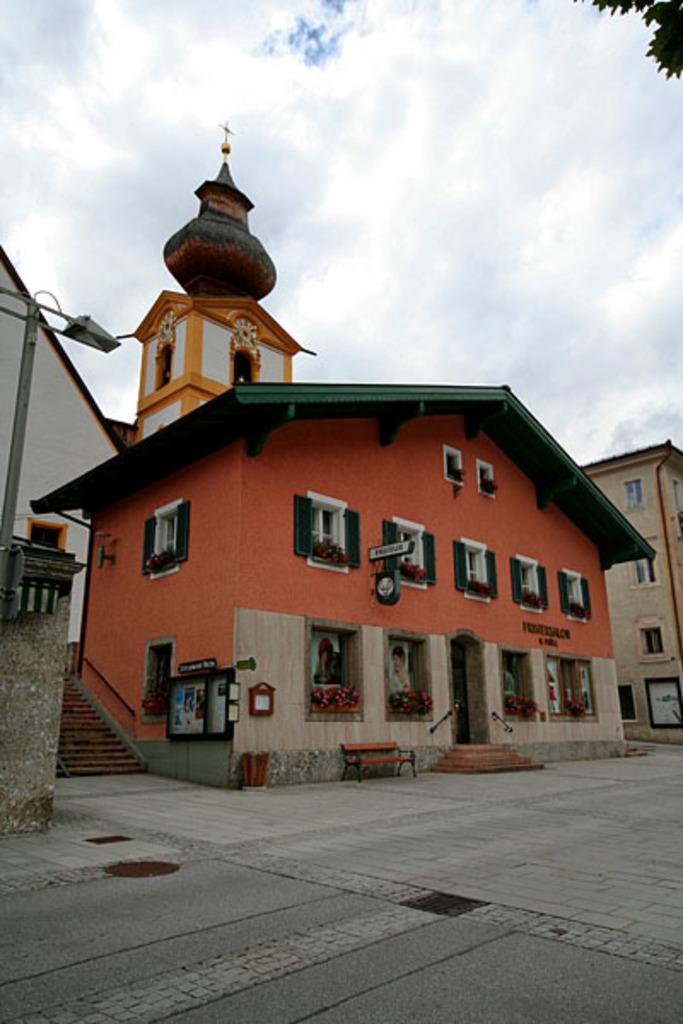What type of structures can be seen on the street in the image? There are houses on the street in the image. What color is the sky in the image? The sky is blue in the image. How many giants are visible in the image? There are no giants present in the image. What time of day is depicted in the image, based on the hour? The provided facts do not mention the time of day or any specific hour, so it cannot be determined from the image. 